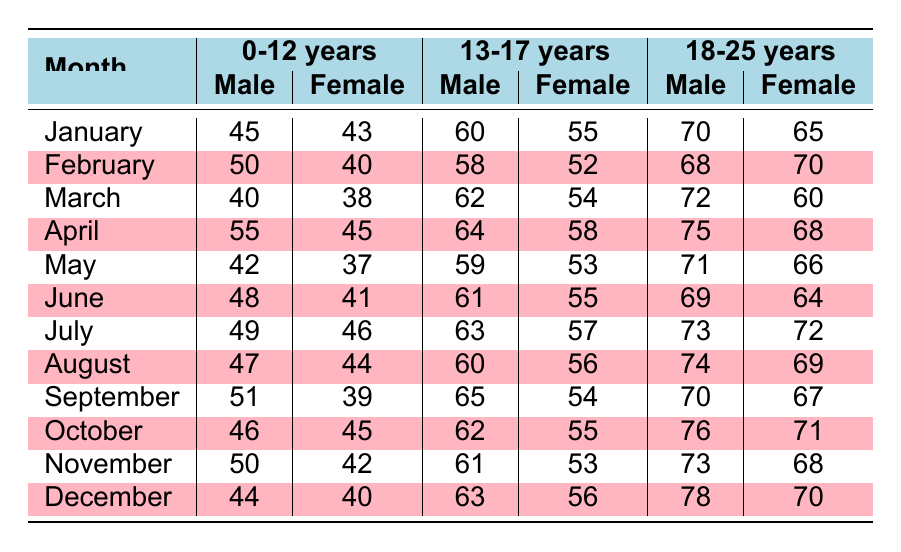What is the total number of missing persons cases reported for females aged 0-12 in January? For females aged 0-12 in January, 43 cases were reported.
Answer: 43 What was the highest number of missing persons cases reported for males aged 13-17 in a single month? The highest number recorded for males aged 13-17 was 65 cases in September.
Answer: 65 Which month had the most missing persons cases reported for females in the 18-25 age group? In February, 70 cases were reported for females aged 18-25, which is the highest across all months.
Answer: February What is the average number of missing persons cases reported for males aged 0-12 throughout the year? The total number of cases for males aged 0-12 over 12 months is (45 + 50 + 40 + 55 + 42 + 48 + 49 + 47 + 51 + 46 + 50 + 44) = 540, and there are 12 months, so the average is 540/12 = 45.
Answer: 45 How many more missing persons cases were reported for males aged 18-25 than for females aged 18-25 in March? In March, 72 cases were reported for males and 60 for females, so the difference is 72 - 60 = 12.
Answer: 12 In which month did the males aged 0-12 show a decrease in reported cases compared to the previous month? A decrease occurred in March, where the cases dropped from 50 in February to 40.
Answer: March What is the total number of missing persons cases reported for females aged 13-17 throughout the year? The total is calculated by adding the cases for each month: (55 + 52 + 54 + 58 + 53 + 55 + 57 + 56 + 54 + 55 + 53 + 56) = 646.
Answer: 646 Did the number of cases reported for females aged 0-12 increase from July to August? No, the cases decreased from 46 in July to 44 in August.
Answer: No What was the monthly average of cases reported for males aged 13-17? The total for males aged 13-17 is (60 + 58 + 62 + 64 + 59 + 61 + 63 + 60 + 65 + 62 + 61 + 63) = 743, so the average is 743/12 ≈ 61.92.
Answer: Approximately 61.92 In December, were there more cases reported for males aged 0-12 than for females in the same age group? Yes, 44 cases were reported for males compared to 40 for females.
Answer: Yes 